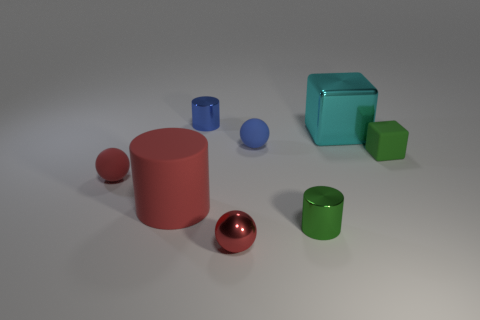Add 2 big brown shiny cylinders. How many objects exist? 10 Subtract all cubes. How many objects are left? 6 Add 5 metal cylinders. How many metal cylinders are left? 7 Add 6 large cyan spheres. How many large cyan spheres exist? 6 Subtract 0 yellow cylinders. How many objects are left? 8 Subtract all red metallic spheres. Subtract all cyan blocks. How many objects are left? 6 